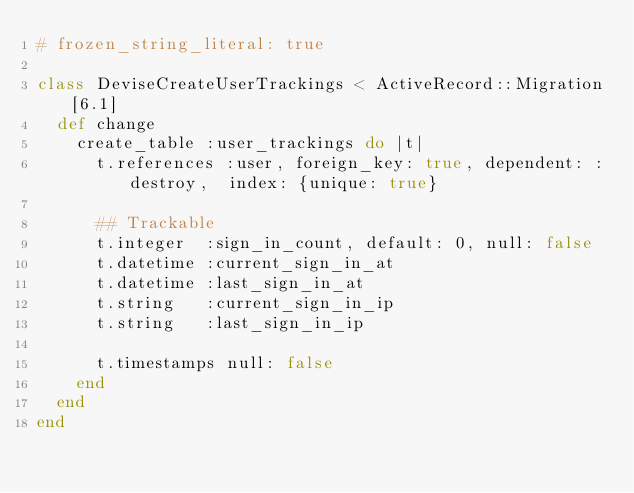Convert code to text. <code><loc_0><loc_0><loc_500><loc_500><_Ruby_># frozen_string_literal: true

class DeviseCreateUserTrackings < ActiveRecord::Migration[6.1]
  def change
    create_table :user_trackings do |t|
      t.references :user, foreign_key: true, dependent: :destroy,  index: {unique: true}

      ## Trackable
      t.integer  :sign_in_count, default: 0, null: false
      t.datetime :current_sign_in_at
      t.datetime :last_sign_in_at
      t.string   :current_sign_in_ip
      t.string   :last_sign_in_ip

      t.timestamps null: false
    end
  end
end
</code> 